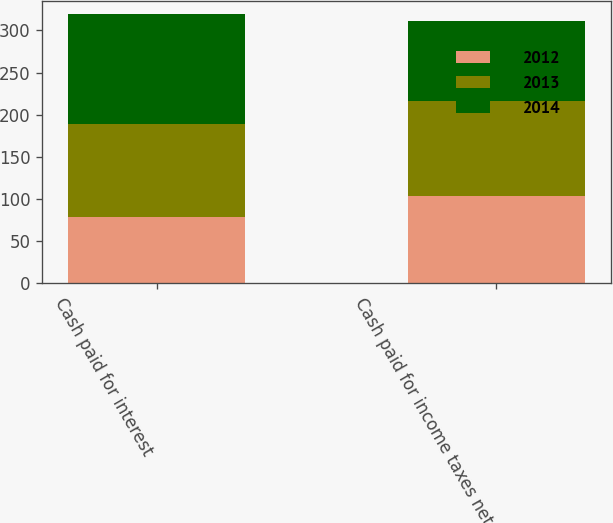Convert chart. <chart><loc_0><loc_0><loc_500><loc_500><stacked_bar_chart><ecel><fcel>Cash paid for interest<fcel>Cash paid for income taxes net<nl><fcel>2012<fcel>78.1<fcel>103.9<nl><fcel>2013<fcel>110.7<fcel>111.8<nl><fcel>2014<fcel>130.6<fcel>95.7<nl></chart> 